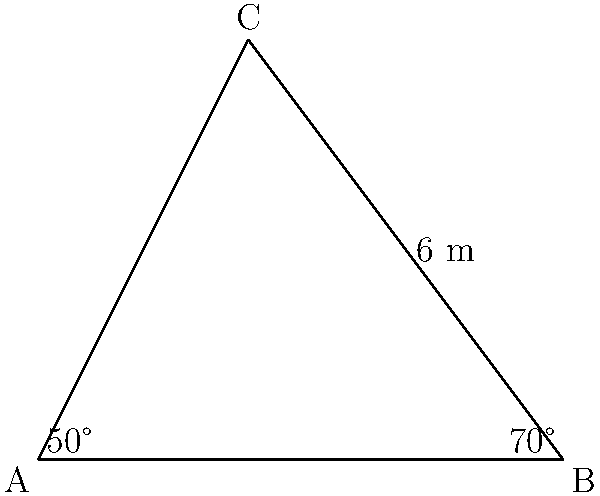A triangular public gathering space is being planned for a community event to promote voter engagement. The space is represented by triangle ABC, where angle A is 50°, angle B is 70°, and the side opposite to angle C (side AB) is 6 meters long. Calculate the area of this triangular space to determine its capacity for the event. To find the area of the triangular space, we can use the formula:

$$\text{Area} = \frac{1}{2}ab\sin(C)$$

Where $a$ and $b$ are two sides of the triangle, and $C$ is the angle between them.

We're given side $c = 6$ m and two angles, but we need to find side $a$ or $b$ to use this formula.

Let's use the law of sines to find side $a$:

$$\frac{a}{\sin(A)} = \frac{c}{\sin(C)}$$

We know $c = 6$ m, $A = 50°$, and $C = 180° - 50° - 70° = 60°$

Substituting:

$$\frac{a}{\sin(50°)} = \frac{6}{\sin(60°)}$$

Solving for $a$:

$$a = \frac{6 \sin(50°)}{\sin(60°)} \approx 5.33 \text{ m}$$

Now we can use the area formula:

$$\text{Area} = \frac{1}{2}ab\sin(C)$$
$$= \frac{1}{2} \cdot 5.33 \cdot 6 \cdot \sin(60°)$$
$$= \frac{1}{2} \cdot 5.33 \cdot 6 \cdot \frac{\sqrt{3}}{2}$$
$$\approx 13.85 \text{ m}^2$$

This area can be used to estimate the capacity of the space for the voter engagement event.
Answer: 13.85 m² 